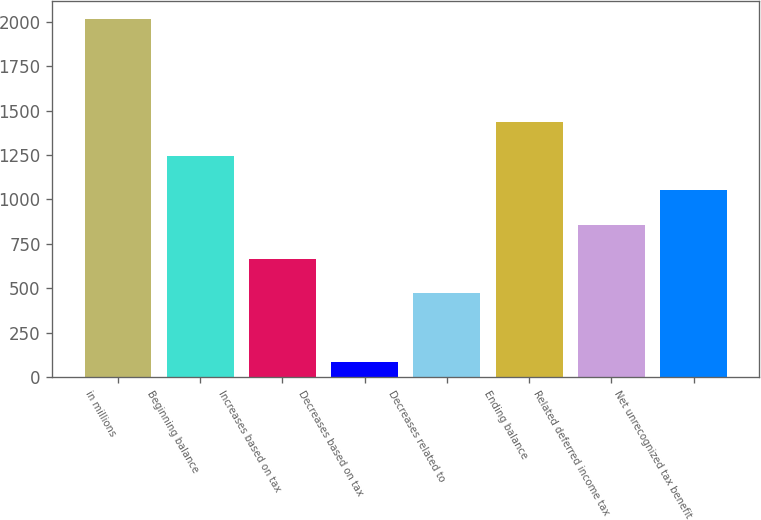Convert chart to OTSL. <chart><loc_0><loc_0><loc_500><loc_500><bar_chart><fcel>in millions<fcel>Beginning balance<fcel>Increases based on tax<fcel>Decreases based on tax<fcel>Decreases related to<fcel>Ending balance<fcel>Related deferred income tax<fcel>Net unrecognized tax benefit<nl><fcel>2016<fcel>1244.8<fcel>666.4<fcel>88<fcel>473.6<fcel>1437.6<fcel>859.2<fcel>1052<nl></chart> 